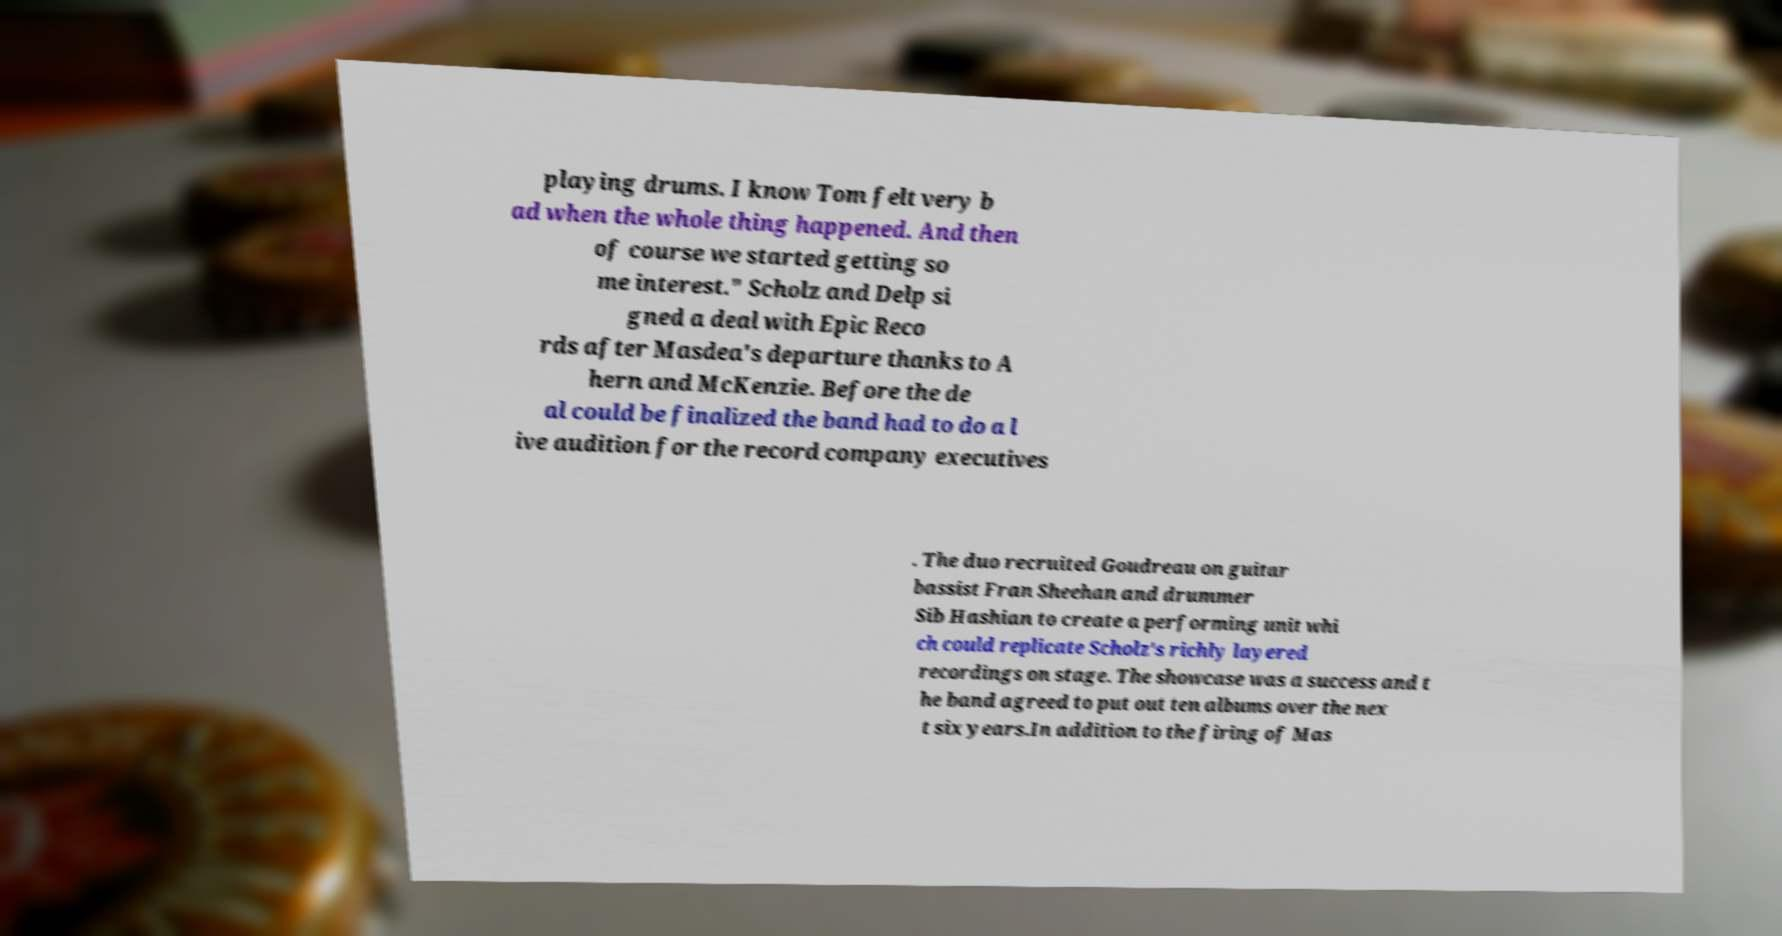There's text embedded in this image that I need extracted. Can you transcribe it verbatim? playing drums. I know Tom felt very b ad when the whole thing happened. And then of course we started getting so me interest." Scholz and Delp si gned a deal with Epic Reco rds after Masdea's departure thanks to A hern and McKenzie. Before the de al could be finalized the band had to do a l ive audition for the record company executives . The duo recruited Goudreau on guitar bassist Fran Sheehan and drummer Sib Hashian to create a performing unit whi ch could replicate Scholz's richly layered recordings on stage. The showcase was a success and t he band agreed to put out ten albums over the nex t six years.In addition to the firing of Mas 